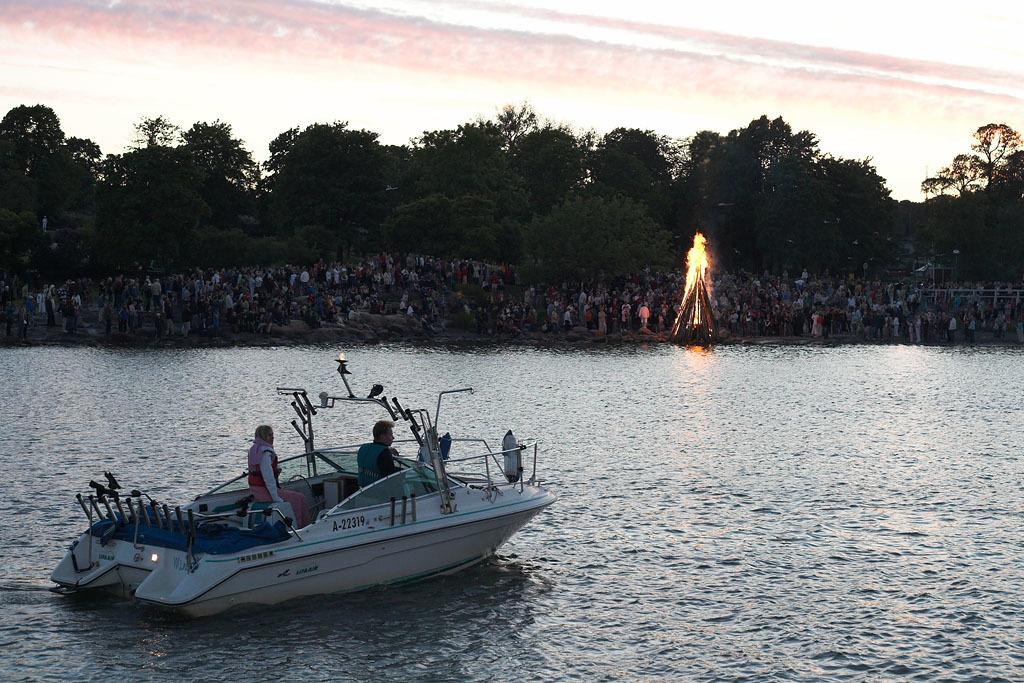What is the main subject of the image? The main subject of the image is a group of people. What else can be seen in the image besides the people? There is a boat on the water and fire beside the water in the image. What can be seen in the background of the image? There are trees visible in the background of the image. What type of mark can be seen on the boat in the image? There is no mark visible on the boat in the image. Can you describe the veins of the trees in the background? There are no veins visible on the trees in the image, as trees do not have veins like animals or humans. 